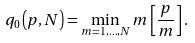Convert formula to latex. <formula><loc_0><loc_0><loc_500><loc_500>q _ { 0 } \left ( p , N \right ) = \min _ { m = 1 , \dots , N } m \left [ \frac { p } { m } \right ] .</formula> 